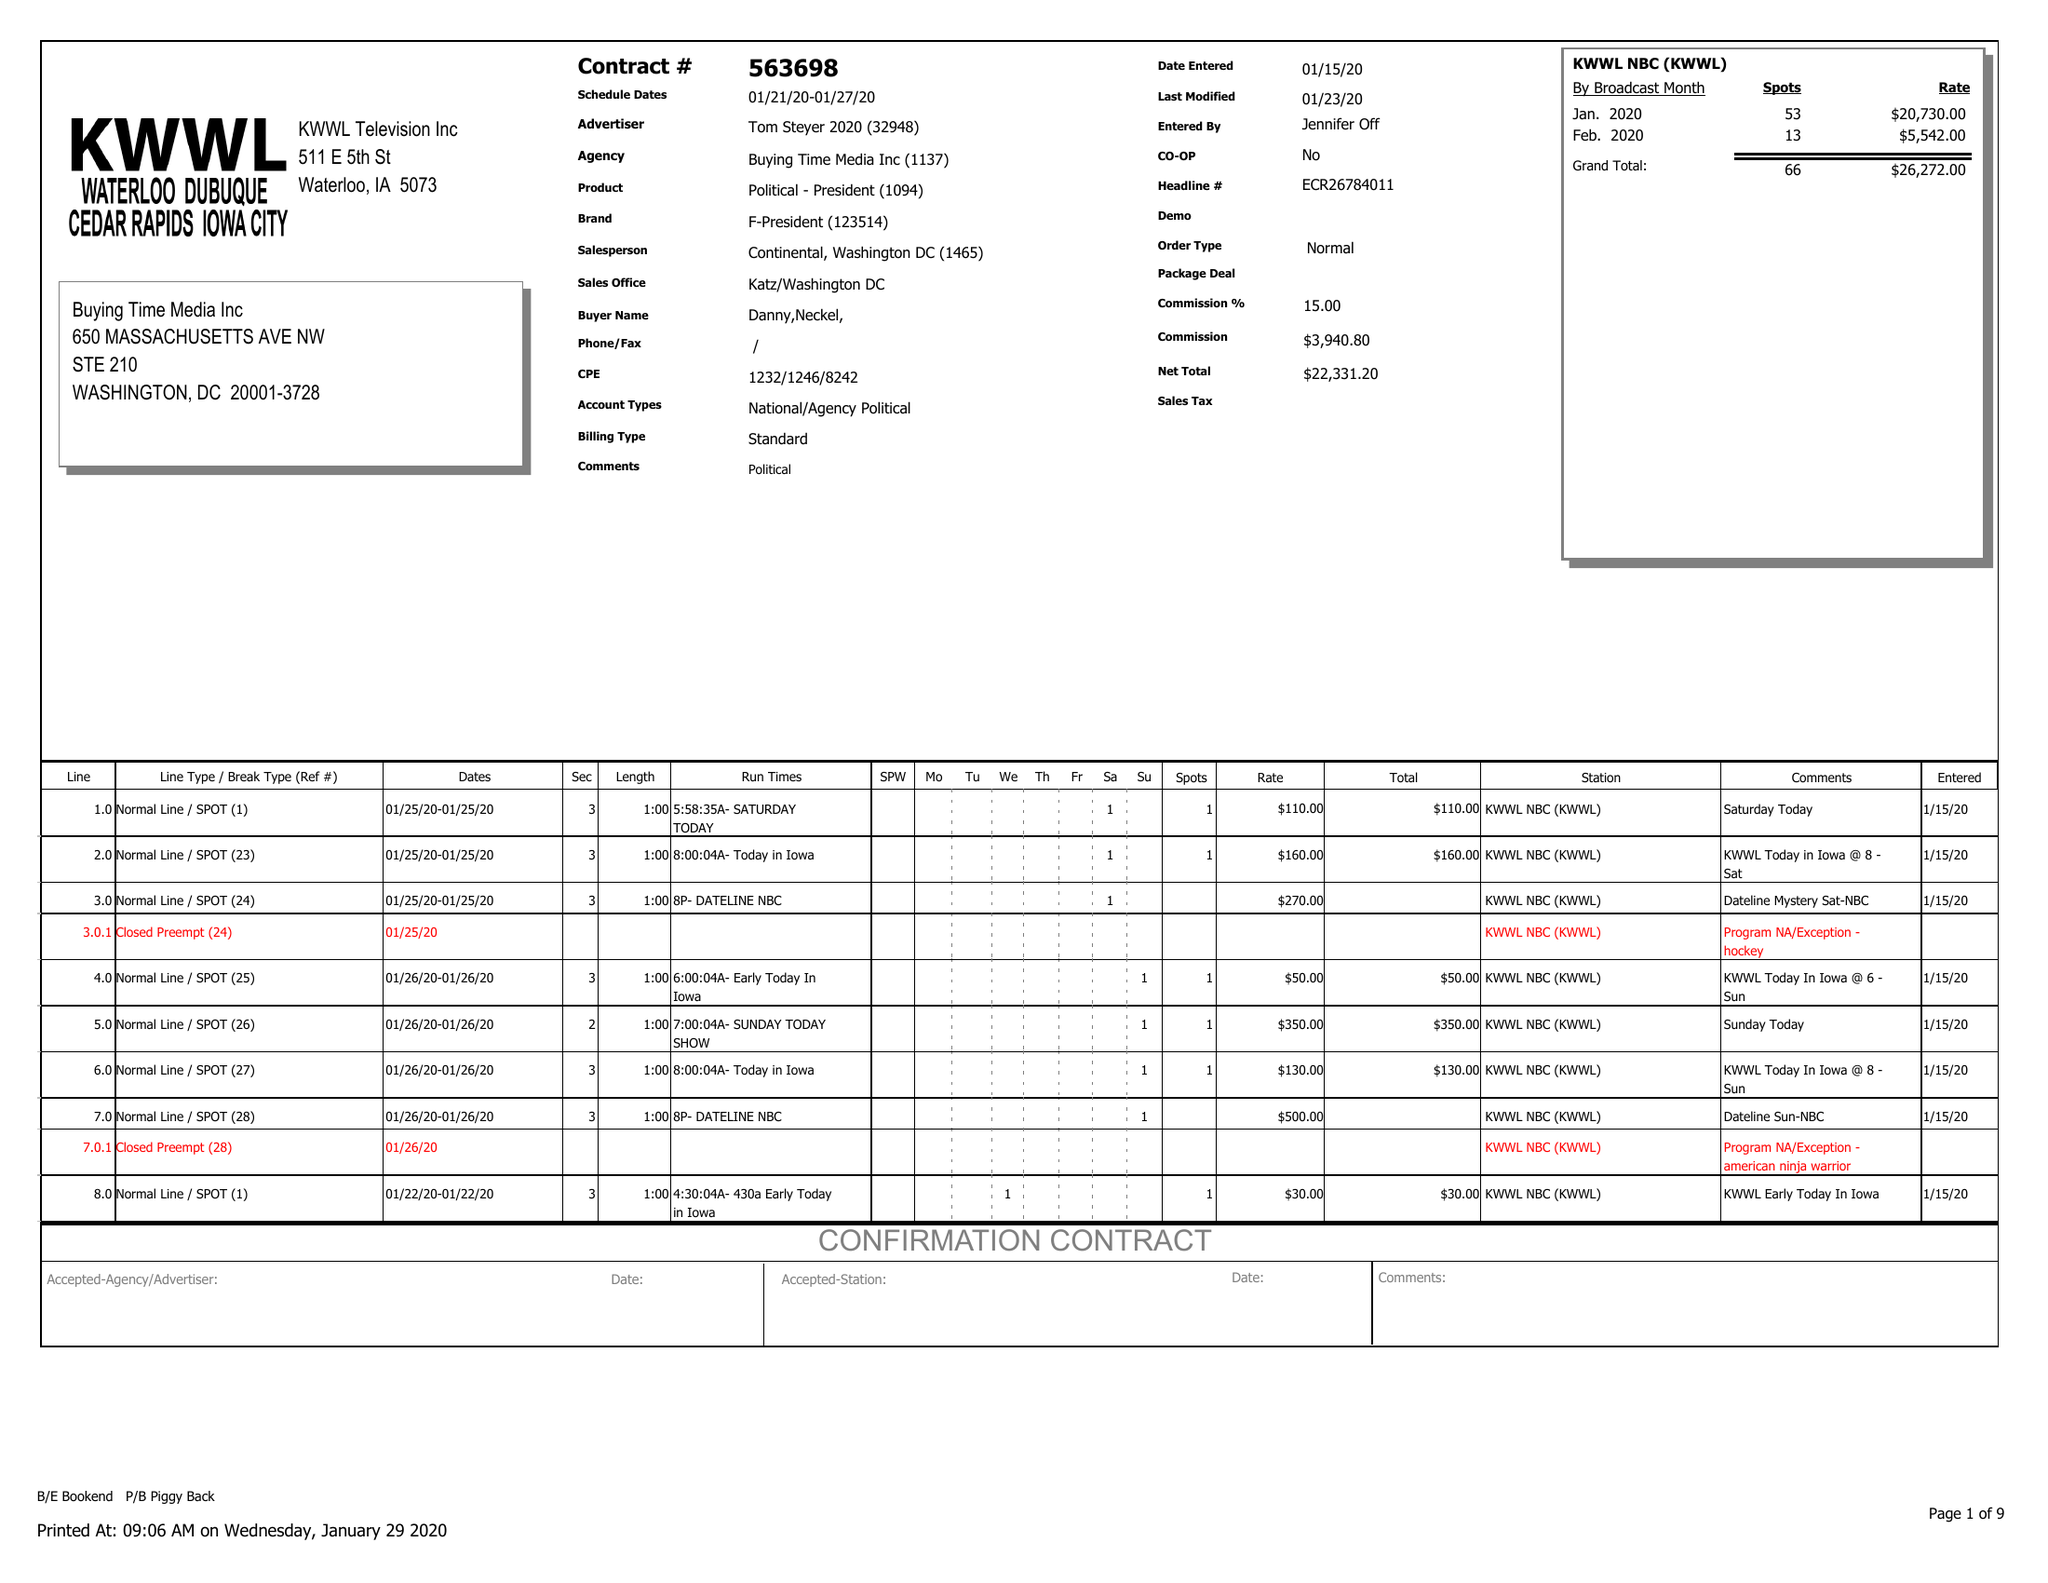What is the value for the gross_amount?
Answer the question using a single word or phrase. 26272.00 